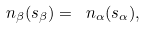Convert formula to latex. <formula><loc_0><loc_0><loc_500><loc_500>\ n _ { \beta } ( s _ { \beta } ) = \ n _ { \alpha } ( s _ { \alpha } ) ,</formula> 